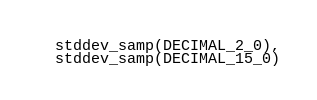<code> <loc_0><loc_0><loc_500><loc_500><_SQL_>  stddev_samp(DECIMAL_2_0),
  stddev_samp(DECIMAL_15_0)</code> 